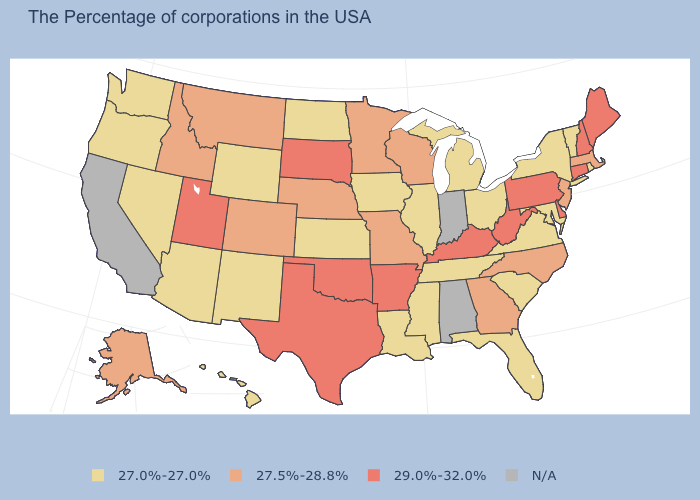Does Utah have the highest value in the West?
Answer briefly. Yes. What is the value of Ohio?
Give a very brief answer. 27.0%-27.0%. Among the states that border Rhode Island , does Massachusetts have the lowest value?
Be succinct. Yes. Name the states that have a value in the range 27.0%-27.0%?
Answer briefly. Rhode Island, Vermont, New York, Maryland, Virginia, South Carolina, Ohio, Florida, Michigan, Tennessee, Illinois, Mississippi, Louisiana, Iowa, Kansas, North Dakota, Wyoming, New Mexico, Arizona, Nevada, Washington, Oregon, Hawaii. What is the value of Massachusetts?
Write a very short answer. 27.5%-28.8%. Among the states that border Oregon , which have the highest value?
Be succinct. Idaho. Does Connecticut have the highest value in the USA?
Answer briefly. Yes. Name the states that have a value in the range 27.5%-28.8%?
Short answer required. Massachusetts, New Jersey, North Carolina, Georgia, Wisconsin, Missouri, Minnesota, Nebraska, Colorado, Montana, Idaho, Alaska. Does New Hampshire have the lowest value in the USA?
Answer briefly. No. What is the value of Tennessee?
Short answer required. 27.0%-27.0%. Among the states that border South Dakota , which have the lowest value?
Be succinct. Iowa, North Dakota, Wyoming. What is the lowest value in the MidWest?
Be succinct. 27.0%-27.0%. What is the value of Connecticut?
Keep it brief. 29.0%-32.0%. What is the value of Missouri?
Give a very brief answer. 27.5%-28.8%. 